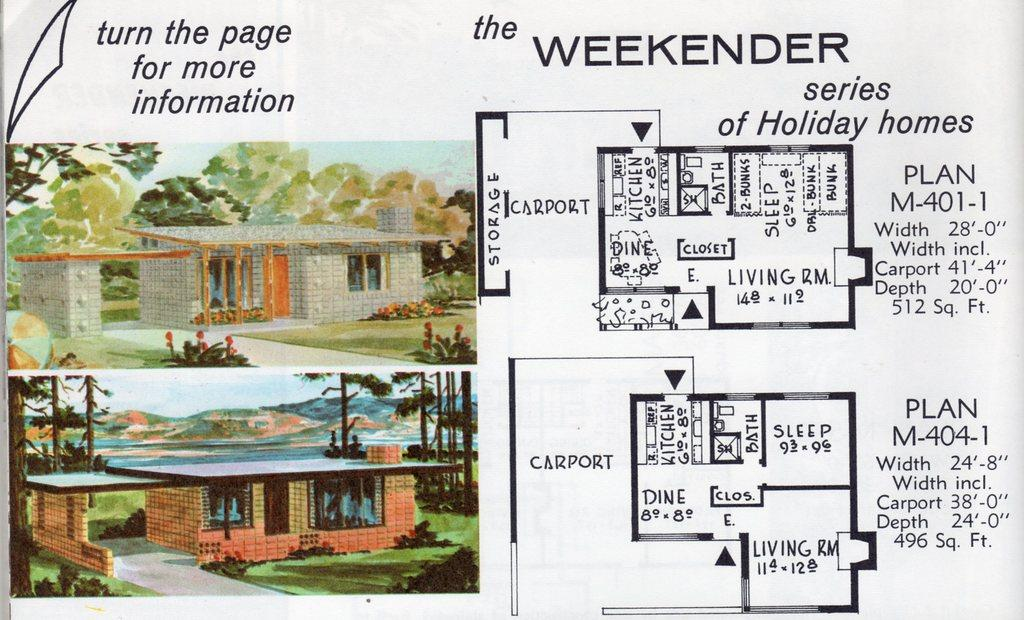<image>
Describe the image concisely. A pamphlet about a home design called the WEEKENDER series of Holiday Homes. 